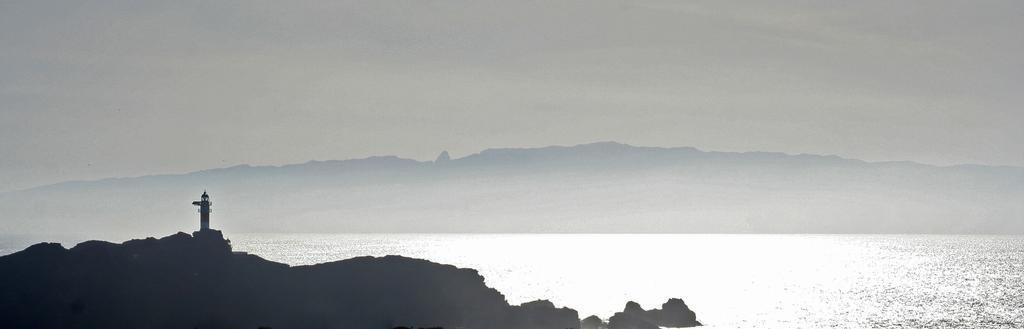In one or two sentences, can you explain what this image depicts? This part of the image is dark, where we can see the rocks and tower house. Here we can see the water, hills and the plain sky in the background. 